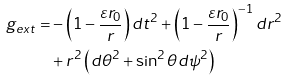<formula> <loc_0><loc_0><loc_500><loc_500>g _ { e x t } = & - \left ( 1 - \frac { \varepsilon r _ { 0 } } { r } \right ) d t ^ { 2 } + \left ( 1 - \frac { \varepsilon r _ { 0 } } { r } \right ) ^ { - 1 } d r ^ { 2 } \\ & + r ^ { 2 } \left ( d \theta ^ { 2 } + \sin ^ { 2 } \theta d \psi ^ { 2 } \right )</formula> 